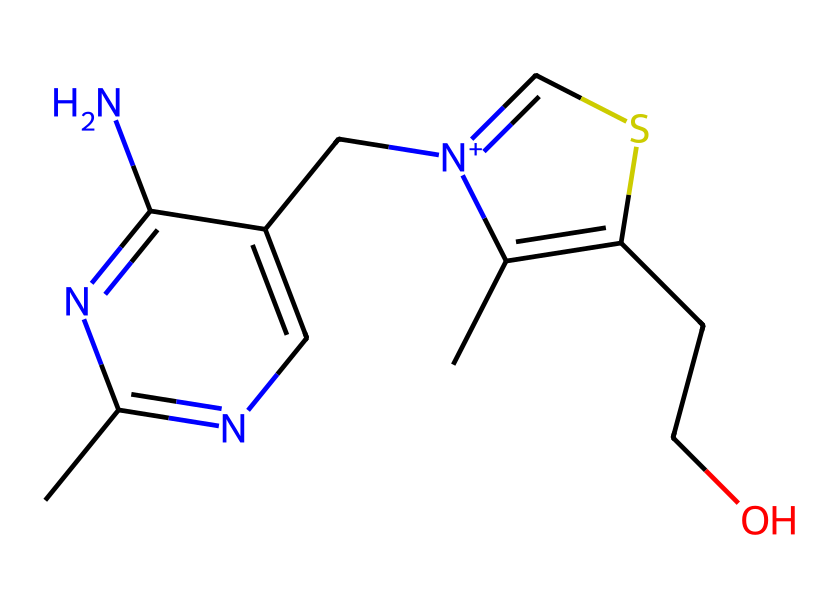How many nitrogen atoms are in thiamine? By examining the SMILES representation, we see that the chemical comprises several nitrogen (N) atoms indicated by 'n' and 'N'. Count the 'n' characters, which represent nitrogen in the ring and side groups. There are a total of four nitrogen atoms in the chemical structure.
Answer: four What type of bond connects the sulfur and carbon in thiamine? In the SMILES structure, the sulfur atom is connected to a carbon atom. This bond is typically a single bond represented without any special notation in SMILES. Therefore, it shows that there is a simple single bond between the sulfur (S) and the carbon (C).
Answer: single bond What is the primary function of thiamine in metabolism? Thiamine is primarily known as a coenzyme involved in the decarboxylation reactions in carbohydrate metabolism. This means it plays a vital role in converting carbohydrates into energy, which is particularly important for students under stress due to energy demands.
Answer: energy metabolism Which functional group is present in this organosulfur compound? Thiamine contains a thiazole ring and an amine functional group. The presence of the sulfur atom in the thiazole ring characterizes it as an organosulfur compound. This combination of features can be easily identified in the SMILES representation.
Answer: thiazole ring What is the overall charge of thiamine? The presence of a nitrogen atom in the side chain with a positive charge (indicated by '[n+]') means that thiamine is positively charged overall. This positively charged group influences its solubility and interaction in biological systems.
Answer: positive charge 